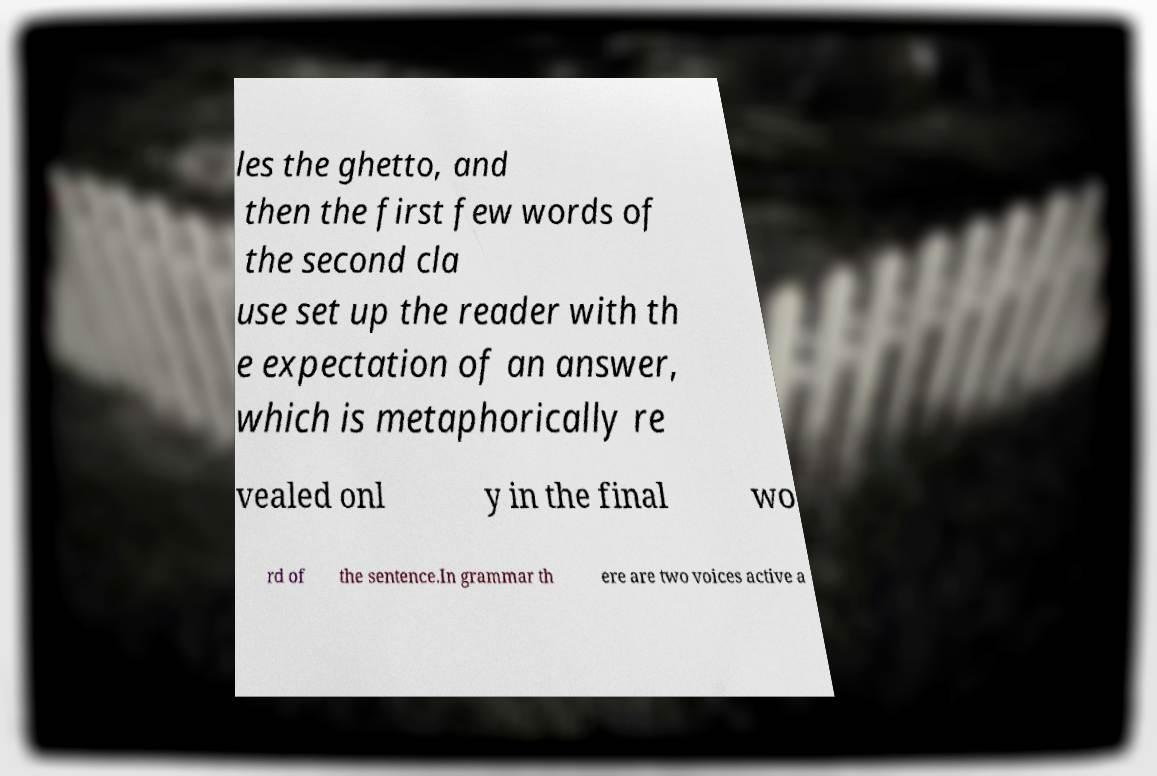For documentation purposes, I need the text within this image transcribed. Could you provide that? les the ghetto, and then the first few words of the second cla use set up the reader with th e expectation of an answer, which is metaphorically re vealed onl y in the final wo rd of the sentence.In grammar th ere are two voices active a 